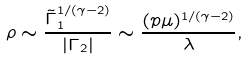Convert formula to latex. <formula><loc_0><loc_0><loc_500><loc_500>\rho \sim \frac { \tilde { \Gamma } _ { 1 } ^ { 1 / ( \gamma - 2 ) } } { | \Gamma _ { 2 } | } \sim \frac { ( p \mu ) ^ { 1 / ( \gamma - 2 ) } } { \lambda } ,</formula> 